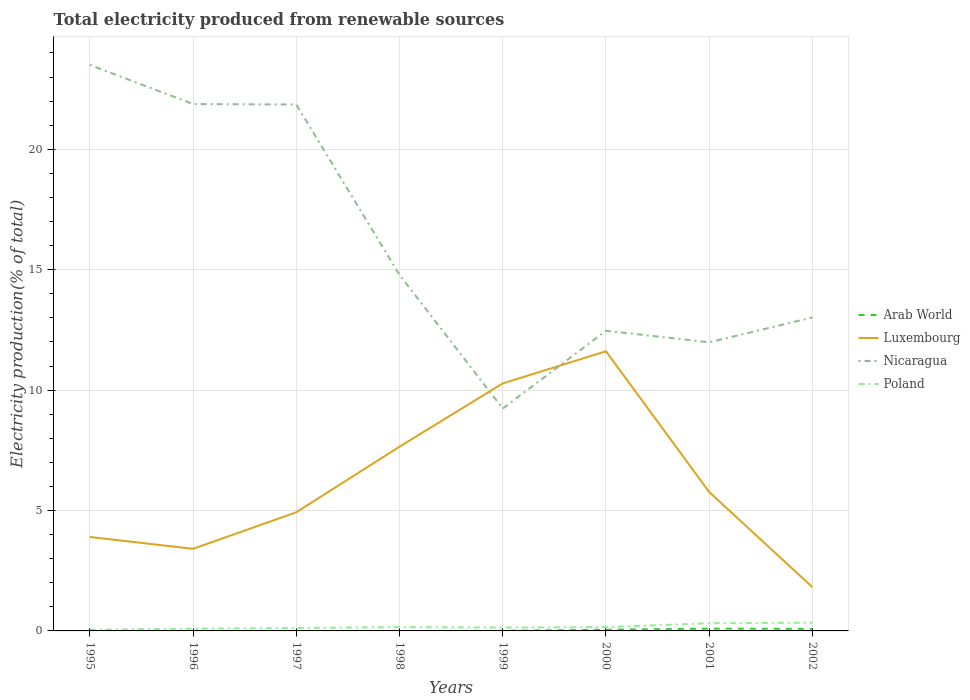Does the line corresponding to Luxembourg intersect with the line corresponding to Poland?
Give a very brief answer. No. Is the number of lines equal to the number of legend labels?
Your answer should be very brief. Yes. Across all years, what is the maximum total electricity produced in Nicaragua?
Give a very brief answer. 9.23. In which year was the total electricity produced in Arab World maximum?
Give a very brief answer. 1996. What is the total total electricity produced in Luxembourg in the graph?
Offer a very short reply. 5.83. What is the difference between the highest and the second highest total electricity produced in Arab World?
Provide a succinct answer. 0.09. How many lines are there?
Ensure brevity in your answer.  4. What is the difference between two consecutive major ticks on the Y-axis?
Your response must be concise. 5. Are the values on the major ticks of Y-axis written in scientific E-notation?
Provide a succinct answer. No. Does the graph contain any zero values?
Keep it short and to the point. No. Where does the legend appear in the graph?
Keep it short and to the point. Center right. How many legend labels are there?
Keep it short and to the point. 4. How are the legend labels stacked?
Provide a succinct answer. Vertical. What is the title of the graph?
Make the answer very short. Total electricity produced from renewable sources. What is the label or title of the X-axis?
Keep it short and to the point. Years. What is the label or title of the Y-axis?
Offer a very short reply. Electricity production(% of total). What is the Electricity production(% of total) in Arab World in 1995?
Your answer should be compact. 0. What is the Electricity production(% of total) of Luxembourg in 1995?
Provide a short and direct response. 3.9. What is the Electricity production(% of total) of Nicaragua in 1995?
Give a very brief answer. 23.5. What is the Electricity production(% of total) in Poland in 1995?
Give a very brief answer. 0.05. What is the Electricity production(% of total) of Arab World in 1996?
Your answer should be very brief. 0. What is the Electricity production(% of total) in Luxembourg in 1996?
Make the answer very short. 3.41. What is the Electricity production(% of total) in Nicaragua in 1996?
Provide a succinct answer. 21.88. What is the Electricity production(% of total) of Poland in 1996?
Offer a terse response. 0.09. What is the Electricity production(% of total) in Arab World in 1997?
Provide a succinct answer. 0. What is the Electricity production(% of total) in Luxembourg in 1997?
Your response must be concise. 4.93. What is the Electricity production(% of total) in Nicaragua in 1997?
Your answer should be very brief. 21.86. What is the Electricity production(% of total) in Poland in 1997?
Your answer should be compact. 0.12. What is the Electricity production(% of total) in Arab World in 1998?
Provide a short and direct response. 0. What is the Electricity production(% of total) in Luxembourg in 1998?
Your response must be concise. 7.65. What is the Electricity production(% of total) in Nicaragua in 1998?
Your response must be concise. 14.78. What is the Electricity production(% of total) of Poland in 1998?
Offer a terse response. 0.16. What is the Electricity production(% of total) of Arab World in 1999?
Your answer should be compact. 0.01. What is the Electricity production(% of total) of Luxembourg in 1999?
Keep it short and to the point. 10.28. What is the Electricity production(% of total) of Nicaragua in 1999?
Keep it short and to the point. 9.23. What is the Electricity production(% of total) of Poland in 1999?
Your answer should be compact. 0.14. What is the Electricity production(% of total) of Arab World in 2000?
Keep it short and to the point. 0.05. What is the Electricity production(% of total) in Luxembourg in 2000?
Provide a short and direct response. 11.61. What is the Electricity production(% of total) in Nicaragua in 2000?
Ensure brevity in your answer.  12.46. What is the Electricity production(% of total) of Poland in 2000?
Offer a very short reply. 0.16. What is the Electricity production(% of total) in Arab World in 2001?
Make the answer very short. 0.09. What is the Electricity production(% of total) in Luxembourg in 2001?
Provide a short and direct response. 5.77. What is the Electricity production(% of total) in Nicaragua in 2001?
Your answer should be compact. 11.98. What is the Electricity production(% of total) in Poland in 2001?
Offer a very short reply. 0.32. What is the Electricity production(% of total) in Arab World in 2002?
Ensure brevity in your answer.  0.08. What is the Electricity production(% of total) of Luxembourg in 2002?
Keep it short and to the point. 1.82. What is the Electricity production(% of total) in Nicaragua in 2002?
Ensure brevity in your answer.  13.02. What is the Electricity production(% of total) of Poland in 2002?
Provide a short and direct response. 0.34. Across all years, what is the maximum Electricity production(% of total) of Arab World?
Offer a terse response. 0.09. Across all years, what is the maximum Electricity production(% of total) of Luxembourg?
Ensure brevity in your answer.  11.61. Across all years, what is the maximum Electricity production(% of total) in Nicaragua?
Provide a short and direct response. 23.5. Across all years, what is the maximum Electricity production(% of total) of Poland?
Your response must be concise. 0.34. Across all years, what is the minimum Electricity production(% of total) in Arab World?
Provide a short and direct response. 0. Across all years, what is the minimum Electricity production(% of total) of Luxembourg?
Offer a very short reply. 1.82. Across all years, what is the minimum Electricity production(% of total) in Nicaragua?
Offer a very short reply. 9.23. Across all years, what is the minimum Electricity production(% of total) in Poland?
Your response must be concise. 0.05. What is the total Electricity production(% of total) in Arab World in the graph?
Your answer should be compact. 0.24. What is the total Electricity production(% of total) in Luxembourg in the graph?
Make the answer very short. 49.36. What is the total Electricity production(% of total) of Nicaragua in the graph?
Your answer should be very brief. 128.72. What is the total Electricity production(% of total) of Poland in the graph?
Give a very brief answer. 1.38. What is the difference between the Electricity production(% of total) in Luxembourg in 1995 and that in 1996?
Offer a very short reply. 0.49. What is the difference between the Electricity production(% of total) of Nicaragua in 1995 and that in 1996?
Your response must be concise. 1.63. What is the difference between the Electricity production(% of total) in Poland in 1995 and that in 1996?
Offer a terse response. -0.04. What is the difference between the Electricity production(% of total) in Arab World in 1995 and that in 1997?
Keep it short and to the point. -0. What is the difference between the Electricity production(% of total) of Luxembourg in 1995 and that in 1997?
Ensure brevity in your answer.  -1.02. What is the difference between the Electricity production(% of total) in Nicaragua in 1995 and that in 1997?
Offer a terse response. 1.65. What is the difference between the Electricity production(% of total) of Poland in 1995 and that in 1997?
Your response must be concise. -0.07. What is the difference between the Electricity production(% of total) in Arab World in 1995 and that in 1998?
Your response must be concise. -0. What is the difference between the Electricity production(% of total) of Luxembourg in 1995 and that in 1998?
Your answer should be very brief. -3.75. What is the difference between the Electricity production(% of total) of Nicaragua in 1995 and that in 1998?
Offer a terse response. 8.72. What is the difference between the Electricity production(% of total) in Poland in 1995 and that in 1998?
Your answer should be compact. -0.11. What is the difference between the Electricity production(% of total) in Arab World in 1995 and that in 1999?
Your answer should be compact. -0.01. What is the difference between the Electricity production(% of total) in Luxembourg in 1995 and that in 1999?
Ensure brevity in your answer.  -6.38. What is the difference between the Electricity production(% of total) in Nicaragua in 1995 and that in 1999?
Your response must be concise. 14.27. What is the difference between the Electricity production(% of total) in Poland in 1995 and that in 1999?
Give a very brief answer. -0.09. What is the difference between the Electricity production(% of total) of Arab World in 1995 and that in 2000?
Give a very brief answer. -0.05. What is the difference between the Electricity production(% of total) of Luxembourg in 1995 and that in 2000?
Ensure brevity in your answer.  -7.71. What is the difference between the Electricity production(% of total) of Nicaragua in 1995 and that in 2000?
Keep it short and to the point. 11.04. What is the difference between the Electricity production(% of total) of Poland in 1995 and that in 2000?
Offer a very short reply. -0.11. What is the difference between the Electricity production(% of total) of Arab World in 1995 and that in 2001?
Offer a terse response. -0.09. What is the difference between the Electricity production(% of total) of Luxembourg in 1995 and that in 2001?
Offer a terse response. -1.87. What is the difference between the Electricity production(% of total) of Nicaragua in 1995 and that in 2001?
Keep it short and to the point. 11.52. What is the difference between the Electricity production(% of total) of Poland in 1995 and that in 2001?
Ensure brevity in your answer.  -0.27. What is the difference between the Electricity production(% of total) in Arab World in 1995 and that in 2002?
Offer a terse response. -0.08. What is the difference between the Electricity production(% of total) in Luxembourg in 1995 and that in 2002?
Provide a succinct answer. 2.09. What is the difference between the Electricity production(% of total) of Nicaragua in 1995 and that in 2002?
Offer a terse response. 10.49. What is the difference between the Electricity production(% of total) of Poland in 1995 and that in 2002?
Provide a succinct answer. -0.29. What is the difference between the Electricity production(% of total) of Arab World in 1996 and that in 1997?
Your response must be concise. -0. What is the difference between the Electricity production(% of total) of Luxembourg in 1996 and that in 1997?
Offer a very short reply. -1.52. What is the difference between the Electricity production(% of total) of Nicaragua in 1996 and that in 1997?
Your answer should be very brief. 0.02. What is the difference between the Electricity production(% of total) of Poland in 1996 and that in 1997?
Provide a succinct answer. -0.03. What is the difference between the Electricity production(% of total) of Arab World in 1996 and that in 1998?
Ensure brevity in your answer.  -0. What is the difference between the Electricity production(% of total) in Luxembourg in 1996 and that in 1998?
Ensure brevity in your answer.  -4.24. What is the difference between the Electricity production(% of total) in Nicaragua in 1996 and that in 1998?
Provide a succinct answer. 7.09. What is the difference between the Electricity production(% of total) in Poland in 1996 and that in 1998?
Your answer should be very brief. -0.06. What is the difference between the Electricity production(% of total) in Arab World in 1996 and that in 1999?
Give a very brief answer. -0.01. What is the difference between the Electricity production(% of total) of Luxembourg in 1996 and that in 1999?
Offer a terse response. -6.87. What is the difference between the Electricity production(% of total) in Nicaragua in 1996 and that in 1999?
Keep it short and to the point. 12.64. What is the difference between the Electricity production(% of total) of Poland in 1996 and that in 1999?
Your answer should be very brief. -0.05. What is the difference between the Electricity production(% of total) of Arab World in 1996 and that in 2000?
Your answer should be very brief. -0.05. What is the difference between the Electricity production(% of total) in Luxembourg in 1996 and that in 2000?
Your response must be concise. -8.2. What is the difference between the Electricity production(% of total) of Nicaragua in 1996 and that in 2000?
Offer a terse response. 9.41. What is the difference between the Electricity production(% of total) in Poland in 1996 and that in 2000?
Ensure brevity in your answer.  -0.06. What is the difference between the Electricity production(% of total) in Arab World in 1996 and that in 2001?
Provide a succinct answer. -0.09. What is the difference between the Electricity production(% of total) in Luxembourg in 1996 and that in 2001?
Give a very brief answer. -2.36. What is the difference between the Electricity production(% of total) of Nicaragua in 1996 and that in 2001?
Provide a succinct answer. 9.89. What is the difference between the Electricity production(% of total) of Poland in 1996 and that in 2001?
Your answer should be very brief. -0.22. What is the difference between the Electricity production(% of total) in Arab World in 1996 and that in 2002?
Your answer should be very brief. -0.08. What is the difference between the Electricity production(% of total) of Luxembourg in 1996 and that in 2002?
Your response must be concise. 1.59. What is the difference between the Electricity production(% of total) in Nicaragua in 1996 and that in 2002?
Offer a very short reply. 8.86. What is the difference between the Electricity production(% of total) of Poland in 1996 and that in 2002?
Keep it short and to the point. -0.25. What is the difference between the Electricity production(% of total) in Luxembourg in 1997 and that in 1998?
Your answer should be compact. -2.72. What is the difference between the Electricity production(% of total) in Nicaragua in 1997 and that in 1998?
Your answer should be compact. 7.07. What is the difference between the Electricity production(% of total) in Poland in 1997 and that in 1998?
Give a very brief answer. -0.04. What is the difference between the Electricity production(% of total) of Arab World in 1997 and that in 1999?
Provide a short and direct response. -0.01. What is the difference between the Electricity production(% of total) in Luxembourg in 1997 and that in 1999?
Your answer should be compact. -5.35. What is the difference between the Electricity production(% of total) of Nicaragua in 1997 and that in 1999?
Provide a succinct answer. 12.62. What is the difference between the Electricity production(% of total) in Poland in 1997 and that in 1999?
Offer a terse response. -0.02. What is the difference between the Electricity production(% of total) of Arab World in 1997 and that in 2000?
Provide a short and direct response. -0.05. What is the difference between the Electricity production(% of total) in Luxembourg in 1997 and that in 2000?
Your answer should be compact. -6.69. What is the difference between the Electricity production(% of total) of Nicaragua in 1997 and that in 2000?
Your answer should be very brief. 9.4. What is the difference between the Electricity production(% of total) in Poland in 1997 and that in 2000?
Your answer should be compact. -0.04. What is the difference between the Electricity production(% of total) of Arab World in 1997 and that in 2001?
Give a very brief answer. -0.09. What is the difference between the Electricity production(% of total) in Luxembourg in 1997 and that in 2001?
Provide a succinct answer. -0.84. What is the difference between the Electricity production(% of total) in Nicaragua in 1997 and that in 2001?
Keep it short and to the point. 9.87. What is the difference between the Electricity production(% of total) in Poland in 1997 and that in 2001?
Your response must be concise. -0.2. What is the difference between the Electricity production(% of total) in Arab World in 1997 and that in 2002?
Offer a very short reply. -0.08. What is the difference between the Electricity production(% of total) of Luxembourg in 1997 and that in 2002?
Provide a short and direct response. 3.11. What is the difference between the Electricity production(% of total) in Nicaragua in 1997 and that in 2002?
Make the answer very short. 8.84. What is the difference between the Electricity production(% of total) of Poland in 1997 and that in 2002?
Keep it short and to the point. -0.22. What is the difference between the Electricity production(% of total) in Arab World in 1998 and that in 1999?
Give a very brief answer. -0.01. What is the difference between the Electricity production(% of total) of Luxembourg in 1998 and that in 1999?
Offer a very short reply. -2.63. What is the difference between the Electricity production(% of total) in Nicaragua in 1998 and that in 1999?
Make the answer very short. 5.55. What is the difference between the Electricity production(% of total) in Poland in 1998 and that in 1999?
Provide a succinct answer. 0.02. What is the difference between the Electricity production(% of total) of Arab World in 1998 and that in 2000?
Your answer should be very brief. -0.05. What is the difference between the Electricity production(% of total) in Luxembourg in 1998 and that in 2000?
Your response must be concise. -3.96. What is the difference between the Electricity production(% of total) of Nicaragua in 1998 and that in 2000?
Provide a succinct answer. 2.32. What is the difference between the Electricity production(% of total) in Poland in 1998 and that in 2000?
Give a very brief answer. 0. What is the difference between the Electricity production(% of total) of Arab World in 1998 and that in 2001?
Make the answer very short. -0.09. What is the difference between the Electricity production(% of total) of Luxembourg in 1998 and that in 2001?
Offer a very short reply. 1.88. What is the difference between the Electricity production(% of total) of Nicaragua in 1998 and that in 2001?
Provide a succinct answer. 2.8. What is the difference between the Electricity production(% of total) in Poland in 1998 and that in 2001?
Your answer should be compact. -0.16. What is the difference between the Electricity production(% of total) of Arab World in 1998 and that in 2002?
Make the answer very short. -0.08. What is the difference between the Electricity production(% of total) of Luxembourg in 1998 and that in 2002?
Provide a succinct answer. 5.83. What is the difference between the Electricity production(% of total) of Nicaragua in 1998 and that in 2002?
Provide a succinct answer. 1.77. What is the difference between the Electricity production(% of total) of Poland in 1998 and that in 2002?
Provide a succinct answer. -0.18. What is the difference between the Electricity production(% of total) in Arab World in 1999 and that in 2000?
Your answer should be compact. -0.04. What is the difference between the Electricity production(% of total) in Luxembourg in 1999 and that in 2000?
Offer a very short reply. -1.33. What is the difference between the Electricity production(% of total) of Nicaragua in 1999 and that in 2000?
Make the answer very short. -3.23. What is the difference between the Electricity production(% of total) in Poland in 1999 and that in 2000?
Offer a terse response. -0.02. What is the difference between the Electricity production(% of total) of Arab World in 1999 and that in 2001?
Your response must be concise. -0.09. What is the difference between the Electricity production(% of total) in Luxembourg in 1999 and that in 2001?
Your response must be concise. 4.51. What is the difference between the Electricity production(% of total) in Nicaragua in 1999 and that in 2001?
Ensure brevity in your answer.  -2.75. What is the difference between the Electricity production(% of total) of Poland in 1999 and that in 2001?
Ensure brevity in your answer.  -0.18. What is the difference between the Electricity production(% of total) in Arab World in 1999 and that in 2002?
Keep it short and to the point. -0.08. What is the difference between the Electricity production(% of total) of Luxembourg in 1999 and that in 2002?
Offer a very short reply. 8.46. What is the difference between the Electricity production(% of total) of Nicaragua in 1999 and that in 2002?
Keep it short and to the point. -3.78. What is the difference between the Electricity production(% of total) of Poland in 1999 and that in 2002?
Provide a short and direct response. -0.2. What is the difference between the Electricity production(% of total) in Arab World in 2000 and that in 2001?
Your response must be concise. -0.04. What is the difference between the Electricity production(% of total) in Luxembourg in 2000 and that in 2001?
Provide a succinct answer. 5.84. What is the difference between the Electricity production(% of total) of Nicaragua in 2000 and that in 2001?
Make the answer very short. 0.48. What is the difference between the Electricity production(% of total) in Poland in 2000 and that in 2001?
Provide a short and direct response. -0.16. What is the difference between the Electricity production(% of total) in Arab World in 2000 and that in 2002?
Provide a succinct answer. -0.03. What is the difference between the Electricity production(% of total) of Luxembourg in 2000 and that in 2002?
Provide a short and direct response. 9.8. What is the difference between the Electricity production(% of total) of Nicaragua in 2000 and that in 2002?
Ensure brevity in your answer.  -0.55. What is the difference between the Electricity production(% of total) of Poland in 2000 and that in 2002?
Offer a terse response. -0.18. What is the difference between the Electricity production(% of total) in Arab World in 2001 and that in 2002?
Your response must be concise. 0.01. What is the difference between the Electricity production(% of total) in Luxembourg in 2001 and that in 2002?
Keep it short and to the point. 3.95. What is the difference between the Electricity production(% of total) of Nicaragua in 2001 and that in 2002?
Your response must be concise. -1.03. What is the difference between the Electricity production(% of total) of Poland in 2001 and that in 2002?
Make the answer very short. -0.02. What is the difference between the Electricity production(% of total) of Arab World in 1995 and the Electricity production(% of total) of Luxembourg in 1996?
Your answer should be very brief. -3.41. What is the difference between the Electricity production(% of total) of Arab World in 1995 and the Electricity production(% of total) of Nicaragua in 1996?
Keep it short and to the point. -21.88. What is the difference between the Electricity production(% of total) of Arab World in 1995 and the Electricity production(% of total) of Poland in 1996?
Offer a terse response. -0.09. What is the difference between the Electricity production(% of total) in Luxembourg in 1995 and the Electricity production(% of total) in Nicaragua in 1996?
Offer a very short reply. -17.98. What is the difference between the Electricity production(% of total) of Luxembourg in 1995 and the Electricity production(% of total) of Poland in 1996?
Your answer should be compact. 3.81. What is the difference between the Electricity production(% of total) of Nicaragua in 1995 and the Electricity production(% of total) of Poland in 1996?
Provide a succinct answer. 23.41. What is the difference between the Electricity production(% of total) in Arab World in 1995 and the Electricity production(% of total) in Luxembourg in 1997?
Keep it short and to the point. -4.93. What is the difference between the Electricity production(% of total) of Arab World in 1995 and the Electricity production(% of total) of Nicaragua in 1997?
Provide a short and direct response. -21.86. What is the difference between the Electricity production(% of total) of Arab World in 1995 and the Electricity production(% of total) of Poland in 1997?
Ensure brevity in your answer.  -0.12. What is the difference between the Electricity production(% of total) of Luxembourg in 1995 and the Electricity production(% of total) of Nicaragua in 1997?
Keep it short and to the point. -17.96. What is the difference between the Electricity production(% of total) in Luxembourg in 1995 and the Electricity production(% of total) in Poland in 1997?
Provide a short and direct response. 3.78. What is the difference between the Electricity production(% of total) in Nicaragua in 1995 and the Electricity production(% of total) in Poland in 1997?
Provide a succinct answer. 23.38. What is the difference between the Electricity production(% of total) of Arab World in 1995 and the Electricity production(% of total) of Luxembourg in 1998?
Give a very brief answer. -7.65. What is the difference between the Electricity production(% of total) of Arab World in 1995 and the Electricity production(% of total) of Nicaragua in 1998?
Provide a short and direct response. -14.78. What is the difference between the Electricity production(% of total) in Arab World in 1995 and the Electricity production(% of total) in Poland in 1998?
Your answer should be very brief. -0.16. What is the difference between the Electricity production(% of total) in Luxembourg in 1995 and the Electricity production(% of total) in Nicaragua in 1998?
Offer a very short reply. -10.88. What is the difference between the Electricity production(% of total) of Luxembourg in 1995 and the Electricity production(% of total) of Poland in 1998?
Keep it short and to the point. 3.74. What is the difference between the Electricity production(% of total) of Nicaragua in 1995 and the Electricity production(% of total) of Poland in 1998?
Your answer should be compact. 23.34. What is the difference between the Electricity production(% of total) in Arab World in 1995 and the Electricity production(% of total) in Luxembourg in 1999?
Offer a terse response. -10.28. What is the difference between the Electricity production(% of total) of Arab World in 1995 and the Electricity production(% of total) of Nicaragua in 1999?
Give a very brief answer. -9.23. What is the difference between the Electricity production(% of total) in Arab World in 1995 and the Electricity production(% of total) in Poland in 1999?
Your answer should be very brief. -0.14. What is the difference between the Electricity production(% of total) of Luxembourg in 1995 and the Electricity production(% of total) of Nicaragua in 1999?
Provide a succinct answer. -5.33. What is the difference between the Electricity production(% of total) of Luxembourg in 1995 and the Electricity production(% of total) of Poland in 1999?
Offer a terse response. 3.76. What is the difference between the Electricity production(% of total) of Nicaragua in 1995 and the Electricity production(% of total) of Poland in 1999?
Offer a terse response. 23.36. What is the difference between the Electricity production(% of total) of Arab World in 1995 and the Electricity production(% of total) of Luxembourg in 2000?
Ensure brevity in your answer.  -11.61. What is the difference between the Electricity production(% of total) of Arab World in 1995 and the Electricity production(% of total) of Nicaragua in 2000?
Your response must be concise. -12.46. What is the difference between the Electricity production(% of total) in Arab World in 1995 and the Electricity production(% of total) in Poland in 2000?
Offer a terse response. -0.16. What is the difference between the Electricity production(% of total) in Luxembourg in 1995 and the Electricity production(% of total) in Nicaragua in 2000?
Provide a short and direct response. -8.56. What is the difference between the Electricity production(% of total) in Luxembourg in 1995 and the Electricity production(% of total) in Poland in 2000?
Provide a short and direct response. 3.74. What is the difference between the Electricity production(% of total) of Nicaragua in 1995 and the Electricity production(% of total) of Poland in 2000?
Keep it short and to the point. 23.35. What is the difference between the Electricity production(% of total) of Arab World in 1995 and the Electricity production(% of total) of Luxembourg in 2001?
Keep it short and to the point. -5.77. What is the difference between the Electricity production(% of total) of Arab World in 1995 and the Electricity production(% of total) of Nicaragua in 2001?
Ensure brevity in your answer.  -11.98. What is the difference between the Electricity production(% of total) in Arab World in 1995 and the Electricity production(% of total) in Poland in 2001?
Give a very brief answer. -0.32. What is the difference between the Electricity production(% of total) in Luxembourg in 1995 and the Electricity production(% of total) in Nicaragua in 2001?
Your answer should be compact. -8.08. What is the difference between the Electricity production(% of total) of Luxembourg in 1995 and the Electricity production(% of total) of Poland in 2001?
Provide a succinct answer. 3.58. What is the difference between the Electricity production(% of total) in Nicaragua in 1995 and the Electricity production(% of total) in Poland in 2001?
Your response must be concise. 23.19. What is the difference between the Electricity production(% of total) of Arab World in 1995 and the Electricity production(% of total) of Luxembourg in 2002?
Your response must be concise. -1.82. What is the difference between the Electricity production(% of total) in Arab World in 1995 and the Electricity production(% of total) in Nicaragua in 2002?
Offer a very short reply. -13.02. What is the difference between the Electricity production(% of total) of Arab World in 1995 and the Electricity production(% of total) of Poland in 2002?
Ensure brevity in your answer.  -0.34. What is the difference between the Electricity production(% of total) in Luxembourg in 1995 and the Electricity production(% of total) in Nicaragua in 2002?
Your response must be concise. -9.11. What is the difference between the Electricity production(% of total) of Luxembourg in 1995 and the Electricity production(% of total) of Poland in 2002?
Keep it short and to the point. 3.56. What is the difference between the Electricity production(% of total) in Nicaragua in 1995 and the Electricity production(% of total) in Poland in 2002?
Offer a very short reply. 23.16. What is the difference between the Electricity production(% of total) of Arab World in 1996 and the Electricity production(% of total) of Luxembourg in 1997?
Offer a terse response. -4.93. What is the difference between the Electricity production(% of total) in Arab World in 1996 and the Electricity production(% of total) in Nicaragua in 1997?
Keep it short and to the point. -21.86. What is the difference between the Electricity production(% of total) of Arab World in 1996 and the Electricity production(% of total) of Poland in 1997?
Make the answer very short. -0.12. What is the difference between the Electricity production(% of total) in Luxembourg in 1996 and the Electricity production(% of total) in Nicaragua in 1997?
Your response must be concise. -18.45. What is the difference between the Electricity production(% of total) of Luxembourg in 1996 and the Electricity production(% of total) of Poland in 1997?
Offer a terse response. 3.29. What is the difference between the Electricity production(% of total) of Nicaragua in 1996 and the Electricity production(% of total) of Poland in 1997?
Keep it short and to the point. 21.76. What is the difference between the Electricity production(% of total) in Arab World in 1996 and the Electricity production(% of total) in Luxembourg in 1998?
Make the answer very short. -7.65. What is the difference between the Electricity production(% of total) of Arab World in 1996 and the Electricity production(% of total) of Nicaragua in 1998?
Ensure brevity in your answer.  -14.78. What is the difference between the Electricity production(% of total) in Arab World in 1996 and the Electricity production(% of total) in Poland in 1998?
Make the answer very short. -0.16. What is the difference between the Electricity production(% of total) in Luxembourg in 1996 and the Electricity production(% of total) in Nicaragua in 1998?
Give a very brief answer. -11.37. What is the difference between the Electricity production(% of total) in Nicaragua in 1996 and the Electricity production(% of total) in Poland in 1998?
Your answer should be compact. 21.72. What is the difference between the Electricity production(% of total) in Arab World in 1996 and the Electricity production(% of total) in Luxembourg in 1999?
Your response must be concise. -10.28. What is the difference between the Electricity production(% of total) in Arab World in 1996 and the Electricity production(% of total) in Nicaragua in 1999?
Ensure brevity in your answer.  -9.23. What is the difference between the Electricity production(% of total) of Arab World in 1996 and the Electricity production(% of total) of Poland in 1999?
Your answer should be compact. -0.14. What is the difference between the Electricity production(% of total) in Luxembourg in 1996 and the Electricity production(% of total) in Nicaragua in 1999?
Your response must be concise. -5.82. What is the difference between the Electricity production(% of total) in Luxembourg in 1996 and the Electricity production(% of total) in Poland in 1999?
Provide a short and direct response. 3.27. What is the difference between the Electricity production(% of total) of Nicaragua in 1996 and the Electricity production(% of total) of Poland in 1999?
Provide a short and direct response. 21.74. What is the difference between the Electricity production(% of total) in Arab World in 1996 and the Electricity production(% of total) in Luxembourg in 2000?
Your answer should be compact. -11.61. What is the difference between the Electricity production(% of total) of Arab World in 1996 and the Electricity production(% of total) of Nicaragua in 2000?
Offer a terse response. -12.46. What is the difference between the Electricity production(% of total) of Arab World in 1996 and the Electricity production(% of total) of Poland in 2000?
Offer a terse response. -0.16. What is the difference between the Electricity production(% of total) in Luxembourg in 1996 and the Electricity production(% of total) in Nicaragua in 2000?
Your answer should be compact. -9.05. What is the difference between the Electricity production(% of total) of Luxembourg in 1996 and the Electricity production(% of total) of Poland in 2000?
Make the answer very short. 3.25. What is the difference between the Electricity production(% of total) of Nicaragua in 1996 and the Electricity production(% of total) of Poland in 2000?
Offer a terse response. 21.72. What is the difference between the Electricity production(% of total) in Arab World in 1996 and the Electricity production(% of total) in Luxembourg in 2001?
Offer a terse response. -5.77. What is the difference between the Electricity production(% of total) of Arab World in 1996 and the Electricity production(% of total) of Nicaragua in 2001?
Offer a terse response. -11.98. What is the difference between the Electricity production(% of total) of Arab World in 1996 and the Electricity production(% of total) of Poland in 2001?
Your answer should be compact. -0.32. What is the difference between the Electricity production(% of total) of Luxembourg in 1996 and the Electricity production(% of total) of Nicaragua in 2001?
Your response must be concise. -8.57. What is the difference between the Electricity production(% of total) in Luxembourg in 1996 and the Electricity production(% of total) in Poland in 2001?
Offer a very short reply. 3.09. What is the difference between the Electricity production(% of total) in Nicaragua in 1996 and the Electricity production(% of total) in Poland in 2001?
Provide a short and direct response. 21.56. What is the difference between the Electricity production(% of total) of Arab World in 1996 and the Electricity production(% of total) of Luxembourg in 2002?
Keep it short and to the point. -1.82. What is the difference between the Electricity production(% of total) of Arab World in 1996 and the Electricity production(% of total) of Nicaragua in 2002?
Provide a succinct answer. -13.02. What is the difference between the Electricity production(% of total) of Arab World in 1996 and the Electricity production(% of total) of Poland in 2002?
Provide a short and direct response. -0.34. What is the difference between the Electricity production(% of total) in Luxembourg in 1996 and the Electricity production(% of total) in Nicaragua in 2002?
Your response must be concise. -9.61. What is the difference between the Electricity production(% of total) of Luxembourg in 1996 and the Electricity production(% of total) of Poland in 2002?
Offer a terse response. 3.07. What is the difference between the Electricity production(% of total) of Nicaragua in 1996 and the Electricity production(% of total) of Poland in 2002?
Offer a terse response. 21.53. What is the difference between the Electricity production(% of total) of Arab World in 1997 and the Electricity production(% of total) of Luxembourg in 1998?
Give a very brief answer. -7.65. What is the difference between the Electricity production(% of total) in Arab World in 1997 and the Electricity production(% of total) in Nicaragua in 1998?
Keep it short and to the point. -14.78. What is the difference between the Electricity production(% of total) of Arab World in 1997 and the Electricity production(% of total) of Poland in 1998?
Provide a short and direct response. -0.16. What is the difference between the Electricity production(% of total) in Luxembourg in 1997 and the Electricity production(% of total) in Nicaragua in 1998?
Offer a very short reply. -9.86. What is the difference between the Electricity production(% of total) in Luxembourg in 1997 and the Electricity production(% of total) in Poland in 1998?
Your answer should be very brief. 4.77. What is the difference between the Electricity production(% of total) in Nicaragua in 1997 and the Electricity production(% of total) in Poland in 1998?
Give a very brief answer. 21.7. What is the difference between the Electricity production(% of total) in Arab World in 1997 and the Electricity production(% of total) in Luxembourg in 1999?
Offer a very short reply. -10.28. What is the difference between the Electricity production(% of total) in Arab World in 1997 and the Electricity production(% of total) in Nicaragua in 1999?
Keep it short and to the point. -9.23. What is the difference between the Electricity production(% of total) in Arab World in 1997 and the Electricity production(% of total) in Poland in 1999?
Provide a succinct answer. -0.14. What is the difference between the Electricity production(% of total) of Luxembourg in 1997 and the Electricity production(% of total) of Nicaragua in 1999?
Offer a very short reply. -4.31. What is the difference between the Electricity production(% of total) in Luxembourg in 1997 and the Electricity production(% of total) in Poland in 1999?
Make the answer very short. 4.79. What is the difference between the Electricity production(% of total) in Nicaragua in 1997 and the Electricity production(% of total) in Poland in 1999?
Your answer should be compact. 21.72. What is the difference between the Electricity production(% of total) in Arab World in 1997 and the Electricity production(% of total) in Luxembourg in 2000?
Offer a very short reply. -11.61. What is the difference between the Electricity production(% of total) of Arab World in 1997 and the Electricity production(% of total) of Nicaragua in 2000?
Ensure brevity in your answer.  -12.46. What is the difference between the Electricity production(% of total) in Arab World in 1997 and the Electricity production(% of total) in Poland in 2000?
Your answer should be compact. -0.16. What is the difference between the Electricity production(% of total) of Luxembourg in 1997 and the Electricity production(% of total) of Nicaragua in 2000?
Offer a terse response. -7.54. What is the difference between the Electricity production(% of total) of Luxembourg in 1997 and the Electricity production(% of total) of Poland in 2000?
Offer a very short reply. 4.77. What is the difference between the Electricity production(% of total) of Nicaragua in 1997 and the Electricity production(% of total) of Poland in 2000?
Your response must be concise. 21.7. What is the difference between the Electricity production(% of total) of Arab World in 1997 and the Electricity production(% of total) of Luxembourg in 2001?
Ensure brevity in your answer.  -5.77. What is the difference between the Electricity production(% of total) of Arab World in 1997 and the Electricity production(% of total) of Nicaragua in 2001?
Provide a succinct answer. -11.98. What is the difference between the Electricity production(% of total) of Arab World in 1997 and the Electricity production(% of total) of Poland in 2001?
Provide a succinct answer. -0.32. What is the difference between the Electricity production(% of total) of Luxembourg in 1997 and the Electricity production(% of total) of Nicaragua in 2001?
Provide a succinct answer. -7.06. What is the difference between the Electricity production(% of total) in Luxembourg in 1997 and the Electricity production(% of total) in Poland in 2001?
Offer a terse response. 4.61. What is the difference between the Electricity production(% of total) of Nicaragua in 1997 and the Electricity production(% of total) of Poland in 2001?
Provide a succinct answer. 21.54. What is the difference between the Electricity production(% of total) in Arab World in 1997 and the Electricity production(% of total) in Luxembourg in 2002?
Your answer should be compact. -1.82. What is the difference between the Electricity production(% of total) in Arab World in 1997 and the Electricity production(% of total) in Nicaragua in 2002?
Offer a terse response. -13.01. What is the difference between the Electricity production(% of total) in Arab World in 1997 and the Electricity production(% of total) in Poland in 2002?
Give a very brief answer. -0.34. What is the difference between the Electricity production(% of total) in Luxembourg in 1997 and the Electricity production(% of total) in Nicaragua in 2002?
Offer a terse response. -8.09. What is the difference between the Electricity production(% of total) of Luxembourg in 1997 and the Electricity production(% of total) of Poland in 2002?
Your response must be concise. 4.58. What is the difference between the Electricity production(% of total) in Nicaragua in 1997 and the Electricity production(% of total) in Poland in 2002?
Provide a short and direct response. 21.52. What is the difference between the Electricity production(% of total) of Arab World in 1998 and the Electricity production(% of total) of Luxembourg in 1999?
Your answer should be compact. -10.28. What is the difference between the Electricity production(% of total) of Arab World in 1998 and the Electricity production(% of total) of Nicaragua in 1999?
Provide a succinct answer. -9.23. What is the difference between the Electricity production(% of total) in Arab World in 1998 and the Electricity production(% of total) in Poland in 1999?
Your answer should be very brief. -0.14. What is the difference between the Electricity production(% of total) in Luxembourg in 1998 and the Electricity production(% of total) in Nicaragua in 1999?
Ensure brevity in your answer.  -1.58. What is the difference between the Electricity production(% of total) in Luxembourg in 1998 and the Electricity production(% of total) in Poland in 1999?
Provide a short and direct response. 7.51. What is the difference between the Electricity production(% of total) in Nicaragua in 1998 and the Electricity production(% of total) in Poland in 1999?
Make the answer very short. 14.64. What is the difference between the Electricity production(% of total) of Arab World in 1998 and the Electricity production(% of total) of Luxembourg in 2000?
Ensure brevity in your answer.  -11.61. What is the difference between the Electricity production(% of total) in Arab World in 1998 and the Electricity production(% of total) in Nicaragua in 2000?
Provide a succinct answer. -12.46. What is the difference between the Electricity production(% of total) in Arab World in 1998 and the Electricity production(% of total) in Poland in 2000?
Your answer should be very brief. -0.16. What is the difference between the Electricity production(% of total) of Luxembourg in 1998 and the Electricity production(% of total) of Nicaragua in 2000?
Your answer should be very brief. -4.81. What is the difference between the Electricity production(% of total) in Luxembourg in 1998 and the Electricity production(% of total) in Poland in 2000?
Make the answer very short. 7.49. What is the difference between the Electricity production(% of total) in Nicaragua in 1998 and the Electricity production(% of total) in Poland in 2000?
Make the answer very short. 14.63. What is the difference between the Electricity production(% of total) in Arab World in 1998 and the Electricity production(% of total) in Luxembourg in 2001?
Give a very brief answer. -5.77. What is the difference between the Electricity production(% of total) of Arab World in 1998 and the Electricity production(% of total) of Nicaragua in 2001?
Provide a short and direct response. -11.98. What is the difference between the Electricity production(% of total) of Arab World in 1998 and the Electricity production(% of total) of Poland in 2001?
Offer a very short reply. -0.32. What is the difference between the Electricity production(% of total) of Luxembourg in 1998 and the Electricity production(% of total) of Nicaragua in 2001?
Your answer should be very brief. -4.33. What is the difference between the Electricity production(% of total) in Luxembourg in 1998 and the Electricity production(% of total) in Poland in 2001?
Offer a terse response. 7.33. What is the difference between the Electricity production(% of total) of Nicaragua in 1998 and the Electricity production(% of total) of Poland in 2001?
Give a very brief answer. 14.47. What is the difference between the Electricity production(% of total) of Arab World in 1998 and the Electricity production(% of total) of Luxembourg in 2002?
Provide a succinct answer. -1.82. What is the difference between the Electricity production(% of total) of Arab World in 1998 and the Electricity production(% of total) of Nicaragua in 2002?
Offer a terse response. -13.01. What is the difference between the Electricity production(% of total) in Arab World in 1998 and the Electricity production(% of total) in Poland in 2002?
Give a very brief answer. -0.34. What is the difference between the Electricity production(% of total) in Luxembourg in 1998 and the Electricity production(% of total) in Nicaragua in 2002?
Offer a very short reply. -5.37. What is the difference between the Electricity production(% of total) of Luxembourg in 1998 and the Electricity production(% of total) of Poland in 2002?
Your answer should be very brief. 7.31. What is the difference between the Electricity production(% of total) in Nicaragua in 1998 and the Electricity production(% of total) in Poland in 2002?
Your response must be concise. 14.44. What is the difference between the Electricity production(% of total) of Arab World in 1999 and the Electricity production(% of total) of Luxembourg in 2000?
Offer a terse response. -11.61. What is the difference between the Electricity production(% of total) in Arab World in 1999 and the Electricity production(% of total) in Nicaragua in 2000?
Offer a very short reply. -12.46. What is the difference between the Electricity production(% of total) of Arab World in 1999 and the Electricity production(% of total) of Poland in 2000?
Ensure brevity in your answer.  -0.15. What is the difference between the Electricity production(% of total) of Luxembourg in 1999 and the Electricity production(% of total) of Nicaragua in 2000?
Make the answer very short. -2.19. What is the difference between the Electricity production(% of total) in Luxembourg in 1999 and the Electricity production(% of total) in Poland in 2000?
Ensure brevity in your answer.  10.12. What is the difference between the Electricity production(% of total) of Nicaragua in 1999 and the Electricity production(% of total) of Poland in 2000?
Your answer should be very brief. 9.08. What is the difference between the Electricity production(% of total) in Arab World in 1999 and the Electricity production(% of total) in Luxembourg in 2001?
Make the answer very short. -5.76. What is the difference between the Electricity production(% of total) of Arab World in 1999 and the Electricity production(% of total) of Nicaragua in 2001?
Give a very brief answer. -11.98. What is the difference between the Electricity production(% of total) in Arab World in 1999 and the Electricity production(% of total) in Poland in 2001?
Your response must be concise. -0.31. What is the difference between the Electricity production(% of total) of Luxembourg in 1999 and the Electricity production(% of total) of Nicaragua in 2001?
Offer a terse response. -1.71. What is the difference between the Electricity production(% of total) of Luxembourg in 1999 and the Electricity production(% of total) of Poland in 2001?
Keep it short and to the point. 9.96. What is the difference between the Electricity production(% of total) in Nicaragua in 1999 and the Electricity production(% of total) in Poland in 2001?
Offer a terse response. 8.91. What is the difference between the Electricity production(% of total) of Arab World in 1999 and the Electricity production(% of total) of Luxembourg in 2002?
Make the answer very short. -1.81. What is the difference between the Electricity production(% of total) in Arab World in 1999 and the Electricity production(% of total) in Nicaragua in 2002?
Your answer should be very brief. -13.01. What is the difference between the Electricity production(% of total) of Arab World in 1999 and the Electricity production(% of total) of Poland in 2002?
Make the answer very short. -0.34. What is the difference between the Electricity production(% of total) of Luxembourg in 1999 and the Electricity production(% of total) of Nicaragua in 2002?
Your answer should be compact. -2.74. What is the difference between the Electricity production(% of total) of Luxembourg in 1999 and the Electricity production(% of total) of Poland in 2002?
Give a very brief answer. 9.94. What is the difference between the Electricity production(% of total) in Nicaragua in 1999 and the Electricity production(% of total) in Poland in 2002?
Your response must be concise. 8.89. What is the difference between the Electricity production(% of total) of Arab World in 2000 and the Electricity production(% of total) of Luxembourg in 2001?
Ensure brevity in your answer.  -5.72. What is the difference between the Electricity production(% of total) in Arab World in 2000 and the Electricity production(% of total) in Nicaragua in 2001?
Offer a terse response. -11.93. What is the difference between the Electricity production(% of total) of Arab World in 2000 and the Electricity production(% of total) of Poland in 2001?
Offer a terse response. -0.27. What is the difference between the Electricity production(% of total) of Luxembourg in 2000 and the Electricity production(% of total) of Nicaragua in 2001?
Provide a short and direct response. -0.37. What is the difference between the Electricity production(% of total) of Luxembourg in 2000 and the Electricity production(% of total) of Poland in 2001?
Provide a succinct answer. 11.29. What is the difference between the Electricity production(% of total) in Nicaragua in 2000 and the Electricity production(% of total) in Poland in 2001?
Make the answer very short. 12.14. What is the difference between the Electricity production(% of total) of Arab World in 2000 and the Electricity production(% of total) of Luxembourg in 2002?
Offer a very short reply. -1.77. What is the difference between the Electricity production(% of total) in Arab World in 2000 and the Electricity production(% of total) in Nicaragua in 2002?
Your response must be concise. -12.97. What is the difference between the Electricity production(% of total) in Arab World in 2000 and the Electricity production(% of total) in Poland in 2002?
Provide a short and direct response. -0.29. What is the difference between the Electricity production(% of total) of Luxembourg in 2000 and the Electricity production(% of total) of Nicaragua in 2002?
Your response must be concise. -1.4. What is the difference between the Electricity production(% of total) of Luxembourg in 2000 and the Electricity production(% of total) of Poland in 2002?
Provide a succinct answer. 11.27. What is the difference between the Electricity production(% of total) of Nicaragua in 2000 and the Electricity production(% of total) of Poland in 2002?
Your answer should be very brief. 12.12. What is the difference between the Electricity production(% of total) of Arab World in 2001 and the Electricity production(% of total) of Luxembourg in 2002?
Offer a very short reply. -1.72. What is the difference between the Electricity production(% of total) of Arab World in 2001 and the Electricity production(% of total) of Nicaragua in 2002?
Ensure brevity in your answer.  -12.92. What is the difference between the Electricity production(% of total) in Arab World in 2001 and the Electricity production(% of total) in Poland in 2002?
Provide a succinct answer. -0.25. What is the difference between the Electricity production(% of total) in Luxembourg in 2001 and the Electricity production(% of total) in Nicaragua in 2002?
Keep it short and to the point. -7.25. What is the difference between the Electricity production(% of total) of Luxembourg in 2001 and the Electricity production(% of total) of Poland in 2002?
Ensure brevity in your answer.  5.42. What is the difference between the Electricity production(% of total) of Nicaragua in 2001 and the Electricity production(% of total) of Poland in 2002?
Provide a succinct answer. 11.64. What is the average Electricity production(% of total) of Arab World per year?
Keep it short and to the point. 0.03. What is the average Electricity production(% of total) in Luxembourg per year?
Provide a succinct answer. 6.17. What is the average Electricity production(% of total) of Nicaragua per year?
Your answer should be compact. 16.09. What is the average Electricity production(% of total) of Poland per year?
Provide a short and direct response. 0.17. In the year 1995, what is the difference between the Electricity production(% of total) of Arab World and Electricity production(% of total) of Luxembourg?
Give a very brief answer. -3.9. In the year 1995, what is the difference between the Electricity production(% of total) in Arab World and Electricity production(% of total) in Nicaragua?
Your answer should be compact. -23.5. In the year 1995, what is the difference between the Electricity production(% of total) of Arab World and Electricity production(% of total) of Poland?
Offer a terse response. -0.05. In the year 1995, what is the difference between the Electricity production(% of total) in Luxembourg and Electricity production(% of total) in Nicaragua?
Your response must be concise. -19.6. In the year 1995, what is the difference between the Electricity production(% of total) in Luxembourg and Electricity production(% of total) in Poland?
Make the answer very short. 3.85. In the year 1995, what is the difference between the Electricity production(% of total) in Nicaragua and Electricity production(% of total) in Poland?
Offer a terse response. 23.45. In the year 1996, what is the difference between the Electricity production(% of total) in Arab World and Electricity production(% of total) in Luxembourg?
Offer a terse response. -3.41. In the year 1996, what is the difference between the Electricity production(% of total) in Arab World and Electricity production(% of total) in Nicaragua?
Make the answer very short. -21.88. In the year 1996, what is the difference between the Electricity production(% of total) in Arab World and Electricity production(% of total) in Poland?
Make the answer very short. -0.09. In the year 1996, what is the difference between the Electricity production(% of total) in Luxembourg and Electricity production(% of total) in Nicaragua?
Make the answer very short. -18.47. In the year 1996, what is the difference between the Electricity production(% of total) in Luxembourg and Electricity production(% of total) in Poland?
Your answer should be compact. 3.31. In the year 1996, what is the difference between the Electricity production(% of total) in Nicaragua and Electricity production(% of total) in Poland?
Offer a very short reply. 21.78. In the year 1997, what is the difference between the Electricity production(% of total) in Arab World and Electricity production(% of total) in Luxembourg?
Your response must be concise. -4.93. In the year 1997, what is the difference between the Electricity production(% of total) of Arab World and Electricity production(% of total) of Nicaragua?
Make the answer very short. -21.86. In the year 1997, what is the difference between the Electricity production(% of total) in Arab World and Electricity production(% of total) in Poland?
Offer a very short reply. -0.12. In the year 1997, what is the difference between the Electricity production(% of total) in Luxembourg and Electricity production(% of total) in Nicaragua?
Ensure brevity in your answer.  -16.93. In the year 1997, what is the difference between the Electricity production(% of total) in Luxembourg and Electricity production(% of total) in Poland?
Provide a short and direct response. 4.8. In the year 1997, what is the difference between the Electricity production(% of total) in Nicaragua and Electricity production(% of total) in Poland?
Ensure brevity in your answer.  21.74. In the year 1998, what is the difference between the Electricity production(% of total) of Arab World and Electricity production(% of total) of Luxembourg?
Keep it short and to the point. -7.65. In the year 1998, what is the difference between the Electricity production(% of total) of Arab World and Electricity production(% of total) of Nicaragua?
Provide a short and direct response. -14.78. In the year 1998, what is the difference between the Electricity production(% of total) of Arab World and Electricity production(% of total) of Poland?
Provide a succinct answer. -0.16. In the year 1998, what is the difference between the Electricity production(% of total) of Luxembourg and Electricity production(% of total) of Nicaragua?
Your answer should be compact. -7.13. In the year 1998, what is the difference between the Electricity production(% of total) in Luxembourg and Electricity production(% of total) in Poland?
Make the answer very short. 7.49. In the year 1998, what is the difference between the Electricity production(% of total) in Nicaragua and Electricity production(% of total) in Poland?
Your response must be concise. 14.62. In the year 1999, what is the difference between the Electricity production(% of total) in Arab World and Electricity production(% of total) in Luxembourg?
Provide a succinct answer. -10.27. In the year 1999, what is the difference between the Electricity production(% of total) in Arab World and Electricity production(% of total) in Nicaragua?
Offer a terse response. -9.23. In the year 1999, what is the difference between the Electricity production(% of total) of Arab World and Electricity production(% of total) of Poland?
Your answer should be very brief. -0.13. In the year 1999, what is the difference between the Electricity production(% of total) in Luxembourg and Electricity production(% of total) in Nicaragua?
Your answer should be very brief. 1.04. In the year 1999, what is the difference between the Electricity production(% of total) in Luxembourg and Electricity production(% of total) in Poland?
Ensure brevity in your answer.  10.14. In the year 1999, what is the difference between the Electricity production(% of total) of Nicaragua and Electricity production(% of total) of Poland?
Give a very brief answer. 9.09. In the year 2000, what is the difference between the Electricity production(% of total) of Arab World and Electricity production(% of total) of Luxembourg?
Your response must be concise. -11.56. In the year 2000, what is the difference between the Electricity production(% of total) in Arab World and Electricity production(% of total) in Nicaragua?
Give a very brief answer. -12.41. In the year 2000, what is the difference between the Electricity production(% of total) of Arab World and Electricity production(% of total) of Poland?
Your answer should be very brief. -0.11. In the year 2000, what is the difference between the Electricity production(% of total) in Luxembourg and Electricity production(% of total) in Nicaragua?
Ensure brevity in your answer.  -0.85. In the year 2000, what is the difference between the Electricity production(% of total) of Luxembourg and Electricity production(% of total) of Poland?
Keep it short and to the point. 11.45. In the year 2000, what is the difference between the Electricity production(% of total) in Nicaragua and Electricity production(% of total) in Poland?
Give a very brief answer. 12.3. In the year 2001, what is the difference between the Electricity production(% of total) of Arab World and Electricity production(% of total) of Luxembourg?
Offer a very short reply. -5.67. In the year 2001, what is the difference between the Electricity production(% of total) of Arab World and Electricity production(% of total) of Nicaragua?
Offer a very short reply. -11.89. In the year 2001, what is the difference between the Electricity production(% of total) of Arab World and Electricity production(% of total) of Poland?
Your response must be concise. -0.22. In the year 2001, what is the difference between the Electricity production(% of total) in Luxembourg and Electricity production(% of total) in Nicaragua?
Keep it short and to the point. -6.22. In the year 2001, what is the difference between the Electricity production(% of total) in Luxembourg and Electricity production(% of total) in Poland?
Offer a very short reply. 5.45. In the year 2001, what is the difference between the Electricity production(% of total) in Nicaragua and Electricity production(% of total) in Poland?
Keep it short and to the point. 11.67. In the year 2002, what is the difference between the Electricity production(% of total) in Arab World and Electricity production(% of total) in Luxembourg?
Offer a very short reply. -1.73. In the year 2002, what is the difference between the Electricity production(% of total) of Arab World and Electricity production(% of total) of Nicaragua?
Offer a very short reply. -12.93. In the year 2002, what is the difference between the Electricity production(% of total) in Arab World and Electricity production(% of total) in Poland?
Make the answer very short. -0.26. In the year 2002, what is the difference between the Electricity production(% of total) in Luxembourg and Electricity production(% of total) in Nicaragua?
Keep it short and to the point. -11.2. In the year 2002, what is the difference between the Electricity production(% of total) of Luxembourg and Electricity production(% of total) of Poland?
Ensure brevity in your answer.  1.47. In the year 2002, what is the difference between the Electricity production(% of total) of Nicaragua and Electricity production(% of total) of Poland?
Ensure brevity in your answer.  12.67. What is the ratio of the Electricity production(% of total) in Arab World in 1995 to that in 1996?
Offer a terse response. 1.05. What is the ratio of the Electricity production(% of total) of Luxembourg in 1995 to that in 1996?
Your response must be concise. 1.14. What is the ratio of the Electricity production(% of total) of Nicaragua in 1995 to that in 1996?
Give a very brief answer. 1.07. What is the ratio of the Electricity production(% of total) of Poland in 1995 to that in 1996?
Your answer should be compact. 0.53. What is the ratio of the Electricity production(% of total) of Arab World in 1995 to that in 1997?
Offer a very short reply. 0.37. What is the ratio of the Electricity production(% of total) of Luxembourg in 1995 to that in 1997?
Make the answer very short. 0.79. What is the ratio of the Electricity production(% of total) of Nicaragua in 1995 to that in 1997?
Provide a succinct answer. 1.08. What is the ratio of the Electricity production(% of total) in Poland in 1995 to that in 1997?
Your answer should be compact. 0.41. What is the ratio of the Electricity production(% of total) of Arab World in 1995 to that in 1998?
Ensure brevity in your answer.  0.4. What is the ratio of the Electricity production(% of total) in Luxembourg in 1995 to that in 1998?
Give a very brief answer. 0.51. What is the ratio of the Electricity production(% of total) of Nicaragua in 1995 to that in 1998?
Give a very brief answer. 1.59. What is the ratio of the Electricity production(% of total) in Poland in 1995 to that in 1998?
Offer a very short reply. 0.31. What is the ratio of the Electricity production(% of total) of Arab World in 1995 to that in 1999?
Your answer should be very brief. 0.05. What is the ratio of the Electricity production(% of total) in Luxembourg in 1995 to that in 1999?
Offer a terse response. 0.38. What is the ratio of the Electricity production(% of total) of Nicaragua in 1995 to that in 1999?
Keep it short and to the point. 2.55. What is the ratio of the Electricity production(% of total) in Poland in 1995 to that in 1999?
Your answer should be very brief. 0.35. What is the ratio of the Electricity production(% of total) in Arab World in 1995 to that in 2000?
Your answer should be compact. 0.01. What is the ratio of the Electricity production(% of total) of Luxembourg in 1995 to that in 2000?
Provide a short and direct response. 0.34. What is the ratio of the Electricity production(% of total) of Nicaragua in 1995 to that in 2000?
Your answer should be very brief. 1.89. What is the ratio of the Electricity production(% of total) in Poland in 1995 to that in 2000?
Offer a very short reply. 0.31. What is the ratio of the Electricity production(% of total) of Arab World in 1995 to that in 2001?
Your response must be concise. 0. What is the ratio of the Electricity production(% of total) of Luxembourg in 1995 to that in 2001?
Keep it short and to the point. 0.68. What is the ratio of the Electricity production(% of total) in Nicaragua in 1995 to that in 2001?
Your answer should be very brief. 1.96. What is the ratio of the Electricity production(% of total) of Poland in 1995 to that in 2001?
Offer a terse response. 0.16. What is the ratio of the Electricity production(% of total) in Arab World in 1995 to that in 2002?
Provide a succinct answer. 0. What is the ratio of the Electricity production(% of total) of Luxembourg in 1995 to that in 2002?
Provide a succinct answer. 2.15. What is the ratio of the Electricity production(% of total) of Nicaragua in 1995 to that in 2002?
Offer a very short reply. 1.81. What is the ratio of the Electricity production(% of total) of Poland in 1995 to that in 2002?
Your answer should be very brief. 0.14. What is the ratio of the Electricity production(% of total) in Arab World in 1996 to that in 1997?
Your answer should be very brief. 0.35. What is the ratio of the Electricity production(% of total) in Luxembourg in 1996 to that in 1997?
Your answer should be compact. 0.69. What is the ratio of the Electricity production(% of total) of Nicaragua in 1996 to that in 1997?
Your answer should be compact. 1. What is the ratio of the Electricity production(% of total) in Poland in 1996 to that in 1997?
Provide a succinct answer. 0.78. What is the ratio of the Electricity production(% of total) in Arab World in 1996 to that in 1998?
Your answer should be compact. 0.38. What is the ratio of the Electricity production(% of total) in Luxembourg in 1996 to that in 1998?
Make the answer very short. 0.45. What is the ratio of the Electricity production(% of total) of Nicaragua in 1996 to that in 1998?
Your answer should be very brief. 1.48. What is the ratio of the Electricity production(% of total) of Poland in 1996 to that in 1998?
Your answer should be compact. 0.59. What is the ratio of the Electricity production(% of total) in Arab World in 1996 to that in 1999?
Give a very brief answer. 0.04. What is the ratio of the Electricity production(% of total) of Luxembourg in 1996 to that in 1999?
Ensure brevity in your answer.  0.33. What is the ratio of the Electricity production(% of total) in Nicaragua in 1996 to that in 1999?
Give a very brief answer. 2.37. What is the ratio of the Electricity production(% of total) in Poland in 1996 to that in 1999?
Your answer should be compact. 0.67. What is the ratio of the Electricity production(% of total) of Arab World in 1996 to that in 2000?
Keep it short and to the point. 0.01. What is the ratio of the Electricity production(% of total) of Luxembourg in 1996 to that in 2000?
Your response must be concise. 0.29. What is the ratio of the Electricity production(% of total) of Nicaragua in 1996 to that in 2000?
Keep it short and to the point. 1.76. What is the ratio of the Electricity production(% of total) in Poland in 1996 to that in 2000?
Keep it short and to the point. 0.6. What is the ratio of the Electricity production(% of total) in Arab World in 1996 to that in 2001?
Provide a short and direct response. 0. What is the ratio of the Electricity production(% of total) of Luxembourg in 1996 to that in 2001?
Your response must be concise. 0.59. What is the ratio of the Electricity production(% of total) in Nicaragua in 1996 to that in 2001?
Offer a terse response. 1.83. What is the ratio of the Electricity production(% of total) of Poland in 1996 to that in 2001?
Provide a short and direct response. 0.3. What is the ratio of the Electricity production(% of total) in Arab World in 1996 to that in 2002?
Provide a succinct answer. 0. What is the ratio of the Electricity production(% of total) of Luxembourg in 1996 to that in 2002?
Your answer should be very brief. 1.88. What is the ratio of the Electricity production(% of total) of Nicaragua in 1996 to that in 2002?
Give a very brief answer. 1.68. What is the ratio of the Electricity production(% of total) of Poland in 1996 to that in 2002?
Your answer should be compact. 0.28. What is the ratio of the Electricity production(% of total) in Arab World in 1997 to that in 1998?
Your answer should be compact. 1.08. What is the ratio of the Electricity production(% of total) in Luxembourg in 1997 to that in 1998?
Give a very brief answer. 0.64. What is the ratio of the Electricity production(% of total) in Nicaragua in 1997 to that in 1998?
Your response must be concise. 1.48. What is the ratio of the Electricity production(% of total) of Poland in 1997 to that in 1998?
Your answer should be compact. 0.76. What is the ratio of the Electricity production(% of total) of Arab World in 1997 to that in 1999?
Provide a short and direct response. 0.13. What is the ratio of the Electricity production(% of total) of Luxembourg in 1997 to that in 1999?
Your response must be concise. 0.48. What is the ratio of the Electricity production(% of total) in Nicaragua in 1997 to that in 1999?
Provide a short and direct response. 2.37. What is the ratio of the Electricity production(% of total) in Poland in 1997 to that in 1999?
Provide a short and direct response. 0.86. What is the ratio of the Electricity production(% of total) of Arab World in 1997 to that in 2000?
Make the answer very short. 0.02. What is the ratio of the Electricity production(% of total) of Luxembourg in 1997 to that in 2000?
Provide a short and direct response. 0.42. What is the ratio of the Electricity production(% of total) of Nicaragua in 1997 to that in 2000?
Provide a succinct answer. 1.75. What is the ratio of the Electricity production(% of total) in Poland in 1997 to that in 2000?
Ensure brevity in your answer.  0.77. What is the ratio of the Electricity production(% of total) of Arab World in 1997 to that in 2001?
Your answer should be compact. 0.01. What is the ratio of the Electricity production(% of total) of Luxembourg in 1997 to that in 2001?
Your answer should be compact. 0.85. What is the ratio of the Electricity production(% of total) in Nicaragua in 1997 to that in 2001?
Provide a short and direct response. 1.82. What is the ratio of the Electricity production(% of total) in Poland in 1997 to that in 2001?
Your response must be concise. 0.38. What is the ratio of the Electricity production(% of total) in Arab World in 1997 to that in 2002?
Provide a succinct answer. 0.01. What is the ratio of the Electricity production(% of total) in Luxembourg in 1997 to that in 2002?
Give a very brief answer. 2.71. What is the ratio of the Electricity production(% of total) of Nicaragua in 1997 to that in 2002?
Your response must be concise. 1.68. What is the ratio of the Electricity production(% of total) in Poland in 1997 to that in 2002?
Give a very brief answer. 0.35. What is the ratio of the Electricity production(% of total) in Arab World in 1998 to that in 1999?
Your answer should be compact. 0.12. What is the ratio of the Electricity production(% of total) in Luxembourg in 1998 to that in 1999?
Make the answer very short. 0.74. What is the ratio of the Electricity production(% of total) in Nicaragua in 1998 to that in 1999?
Your answer should be compact. 1.6. What is the ratio of the Electricity production(% of total) in Poland in 1998 to that in 1999?
Offer a terse response. 1.13. What is the ratio of the Electricity production(% of total) in Arab World in 1998 to that in 2000?
Keep it short and to the point. 0.01. What is the ratio of the Electricity production(% of total) in Luxembourg in 1998 to that in 2000?
Provide a succinct answer. 0.66. What is the ratio of the Electricity production(% of total) in Nicaragua in 1998 to that in 2000?
Ensure brevity in your answer.  1.19. What is the ratio of the Electricity production(% of total) in Arab World in 1998 to that in 2001?
Give a very brief answer. 0.01. What is the ratio of the Electricity production(% of total) in Luxembourg in 1998 to that in 2001?
Give a very brief answer. 1.33. What is the ratio of the Electricity production(% of total) in Nicaragua in 1998 to that in 2001?
Keep it short and to the point. 1.23. What is the ratio of the Electricity production(% of total) of Poland in 1998 to that in 2001?
Your answer should be very brief. 0.5. What is the ratio of the Electricity production(% of total) in Arab World in 1998 to that in 2002?
Provide a short and direct response. 0.01. What is the ratio of the Electricity production(% of total) of Luxembourg in 1998 to that in 2002?
Make the answer very short. 4.21. What is the ratio of the Electricity production(% of total) of Nicaragua in 1998 to that in 2002?
Make the answer very short. 1.14. What is the ratio of the Electricity production(% of total) of Poland in 1998 to that in 2002?
Make the answer very short. 0.46. What is the ratio of the Electricity production(% of total) in Arab World in 1999 to that in 2000?
Your answer should be compact. 0.13. What is the ratio of the Electricity production(% of total) in Luxembourg in 1999 to that in 2000?
Provide a succinct answer. 0.89. What is the ratio of the Electricity production(% of total) in Nicaragua in 1999 to that in 2000?
Ensure brevity in your answer.  0.74. What is the ratio of the Electricity production(% of total) in Poland in 1999 to that in 2000?
Your response must be concise. 0.89. What is the ratio of the Electricity production(% of total) of Arab World in 1999 to that in 2001?
Your answer should be very brief. 0.07. What is the ratio of the Electricity production(% of total) of Luxembourg in 1999 to that in 2001?
Offer a terse response. 1.78. What is the ratio of the Electricity production(% of total) in Nicaragua in 1999 to that in 2001?
Ensure brevity in your answer.  0.77. What is the ratio of the Electricity production(% of total) in Poland in 1999 to that in 2001?
Give a very brief answer. 0.44. What is the ratio of the Electricity production(% of total) in Arab World in 1999 to that in 2002?
Give a very brief answer. 0.07. What is the ratio of the Electricity production(% of total) of Luxembourg in 1999 to that in 2002?
Your answer should be very brief. 5.66. What is the ratio of the Electricity production(% of total) of Nicaragua in 1999 to that in 2002?
Keep it short and to the point. 0.71. What is the ratio of the Electricity production(% of total) of Poland in 1999 to that in 2002?
Make the answer very short. 0.41. What is the ratio of the Electricity production(% of total) of Arab World in 2000 to that in 2001?
Ensure brevity in your answer.  0.52. What is the ratio of the Electricity production(% of total) of Luxembourg in 2000 to that in 2001?
Your response must be concise. 2.01. What is the ratio of the Electricity production(% of total) of Nicaragua in 2000 to that in 2001?
Your answer should be compact. 1.04. What is the ratio of the Electricity production(% of total) of Poland in 2000 to that in 2001?
Make the answer very short. 0.5. What is the ratio of the Electricity production(% of total) in Arab World in 2000 to that in 2002?
Provide a short and direct response. 0.59. What is the ratio of the Electricity production(% of total) of Luxembourg in 2000 to that in 2002?
Your answer should be very brief. 6.39. What is the ratio of the Electricity production(% of total) of Nicaragua in 2000 to that in 2002?
Give a very brief answer. 0.96. What is the ratio of the Electricity production(% of total) of Poland in 2000 to that in 2002?
Keep it short and to the point. 0.46. What is the ratio of the Electricity production(% of total) in Arab World in 2001 to that in 2002?
Offer a terse response. 1.12. What is the ratio of the Electricity production(% of total) of Luxembourg in 2001 to that in 2002?
Provide a short and direct response. 3.18. What is the ratio of the Electricity production(% of total) of Nicaragua in 2001 to that in 2002?
Ensure brevity in your answer.  0.92. What is the ratio of the Electricity production(% of total) of Poland in 2001 to that in 2002?
Offer a very short reply. 0.93. What is the difference between the highest and the second highest Electricity production(% of total) of Arab World?
Provide a short and direct response. 0.01. What is the difference between the highest and the second highest Electricity production(% of total) of Luxembourg?
Your response must be concise. 1.33. What is the difference between the highest and the second highest Electricity production(% of total) in Nicaragua?
Offer a very short reply. 1.63. What is the difference between the highest and the second highest Electricity production(% of total) in Poland?
Your answer should be very brief. 0.02. What is the difference between the highest and the lowest Electricity production(% of total) of Arab World?
Ensure brevity in your answer.  0.09. What is the difference between the highest and the lowest Electricity production(% of total) in Luxembourg?
Make the answer very short. 9.8. What is the difference between the highest and the lowest Electricity production(% of total) in Nicaragua?
Make the answer very short. 14.27. What is the difference between the highest and the lowest Electricity production(% of total) of Poland?
Make the answer very short. 0.29. 